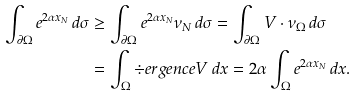Convert formula to latex. <formula><loc_0><loc_0><loc_500><loc_500>\int _ { \partial \Omega } e ^ { 2 \alpha x _ { N } } \, d \sigma & \geq \int _ { \partial \Omega } e ^ { 2 \alpha x _ { N } } \nu _ { N } \, d \sigma = \int _ { \partial \Omega } V \cdot \nu _ { \Omega } \, d \sigma \\ & = \int _ { \Omega } \div e r g e n c e V \, d x = 2 \alpha \int _ { \Omega } e ^ { 2 \alpha x _ { N } } \, d x .</formula> 